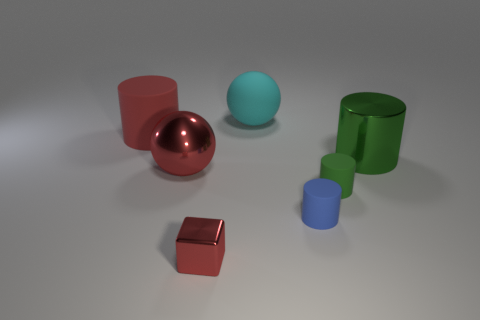Subtract all big red matte cylinders. How many cylinders are left? 3 Subtract all red cylinders. How many cylinders are left? 3 Add 3 tiny blue rubber cylinders. How many objects exist? 10 Subtract all purple cubes. How many green cylinders are left? 2 Subtract all cylinders. How many objects are left? 3 Subtract 2 spheres. How many spheres are left? 0 Add 5 blue cylinders. How many blue cylinders are left? 6 Add 5 red balls. How many red balls exist? 6 Subtract 0 purple blocks. How many objects are left? 7 Subtract all gray balls. Subtract all yellow cylinders. How many balls are left? 2 